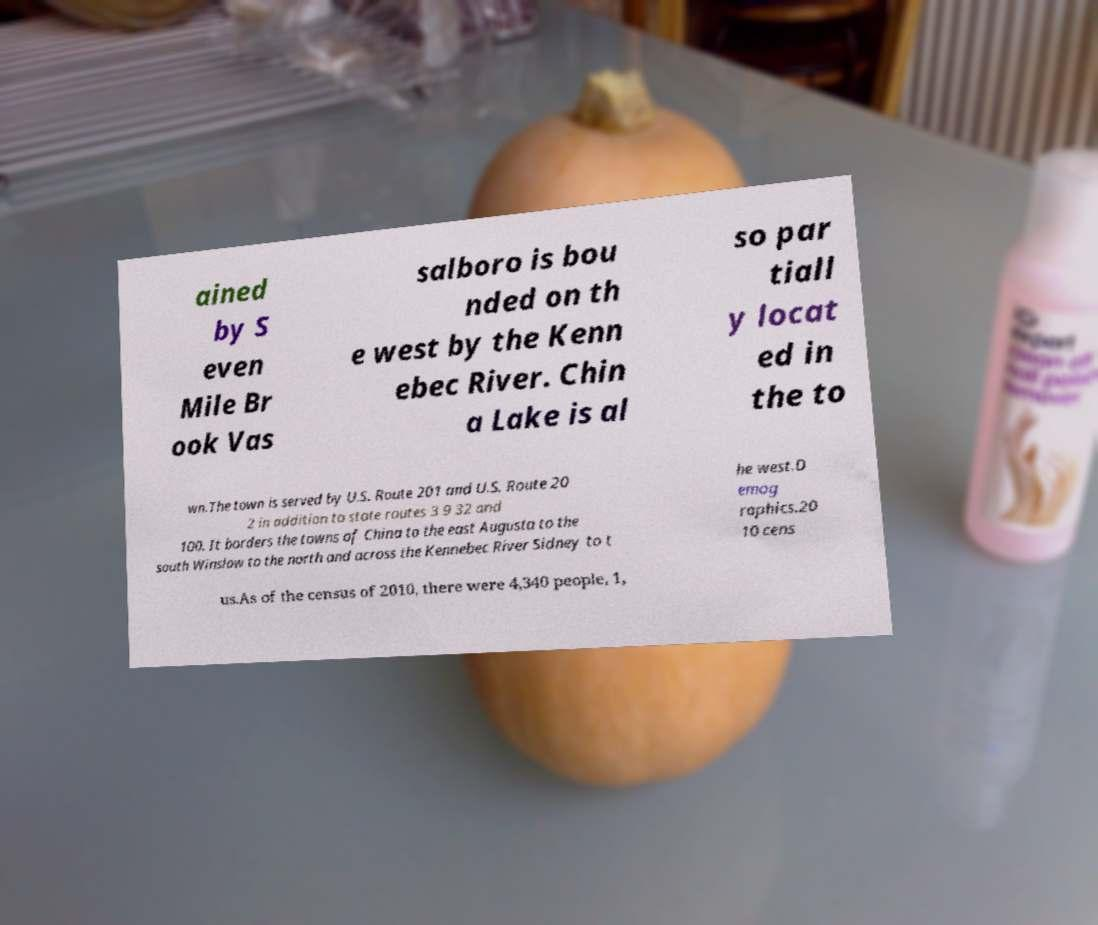Please identify and transcribe the text found in this image. ained by S even Mile Br ook Vas salboro is bou nded on th e west by the Kenn ebec River. Chin a Lake is al so par tiall y locat ed in the to wn.The town is served by U.S. Route 201 and U.S. Route 20 2 in addition to state routes 3 9 32 and 100. It borders the towns of China to the east Augusta to the south Winslow to the north and across the Kennebec River Sidney to t he west.D emog raphics.20 10 cens us.As of the census of 2010, there were 4,340 people, 1, 